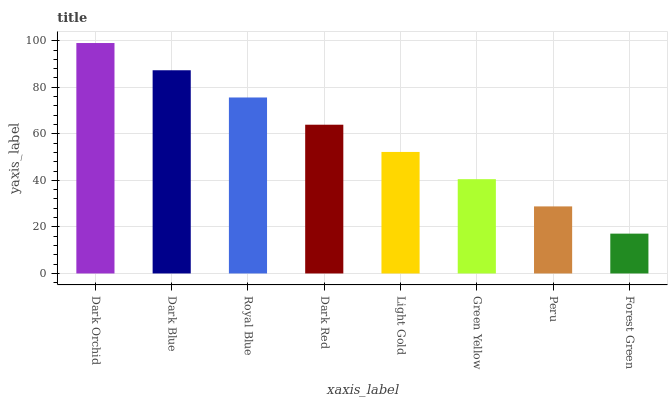Is Forest Green the minimum?
Answer yes or no. Yes. Is Dark Orchid the maximum?
Answer yes or no. Yes. Is Dark Blue the minimum?
Answer yes or no. No. Is Dark Blue the maximum?
Answer yes or no. No. Is Dark Orchid greater than Dark Blue?
Answer yes or no. Yes. Is Dark Blue less than Dark Orchid?
Answer yes or no. Yes. Is Dark Blue greater than Dark Orchid?
Answer yes or no. No. Is Dark Orchid less than Dark Blue?
Answer yes or no. No. Is Dark Red the high median?
Answer yes or no. Yes. Is Light Gold the low median?
Answer yes or no. Yes. Is Green Yellow the high median?
Answer yes or no. No. Is Dark Orchid the low median?
Answer yes or no. No. 